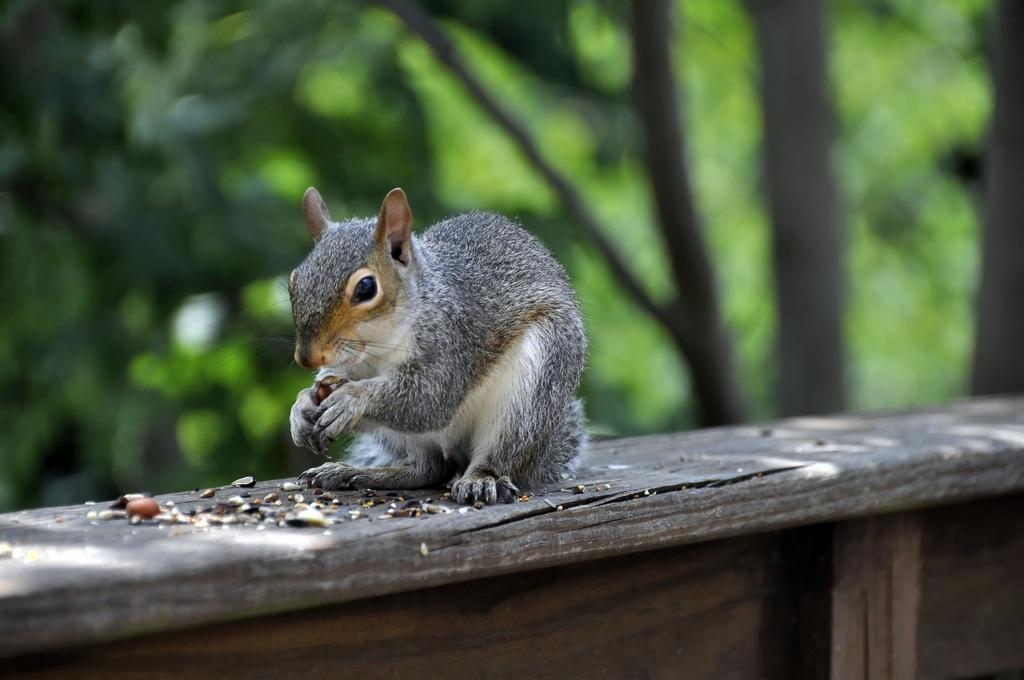What type of animal can be seen in the image? There is a squirrel in the image. What is the squirrel interacting with in the image? There is a food item in the image that the squirrel is likely interacting with. What type of surface is the squirrel and food item on? The wooden surface is present in the image. What colors are present in the background of the image? The background of the image has blue and green colors. How many babies are visible in the image? There are no babies present in the image. What type of elbow is used to hold the food item in the image? There is no elbow present in the image, as it features a squirrel interacting with a food item on a wooden surface. 